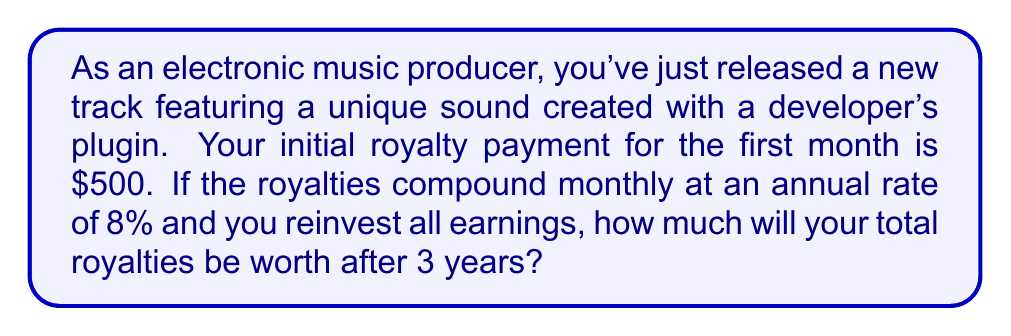Could you help me with this problem? To solve this problem, we'll use the compound interest formula:

$$A = P(1 + \frac{r}{n})^{nt}$$

Where:
$A$ = final amount
$P$ = principal (initial investment)
$r$ = annual interest rate (in decimal form)
$n$ = number of times interest is compounded per year
$t$ = number of years

Given:
$P = \$500$
$r = 8\% = 0.08$
$n = 12$ (compounded monthly)
$t = 3$ years

Let's plug these values into the formula:

$$A = 500(1 + \frac{0.08}{12})^{12 \cdot 3}$$

$$A = 500(1 + 0.00667)^{36}$$

$$A = 500(1.00667)^{36}$$

Using a calculator or computer:

$$A = 500 \cdot 1.2697$$

$$A = 634.85$$
Answer: $634.85 